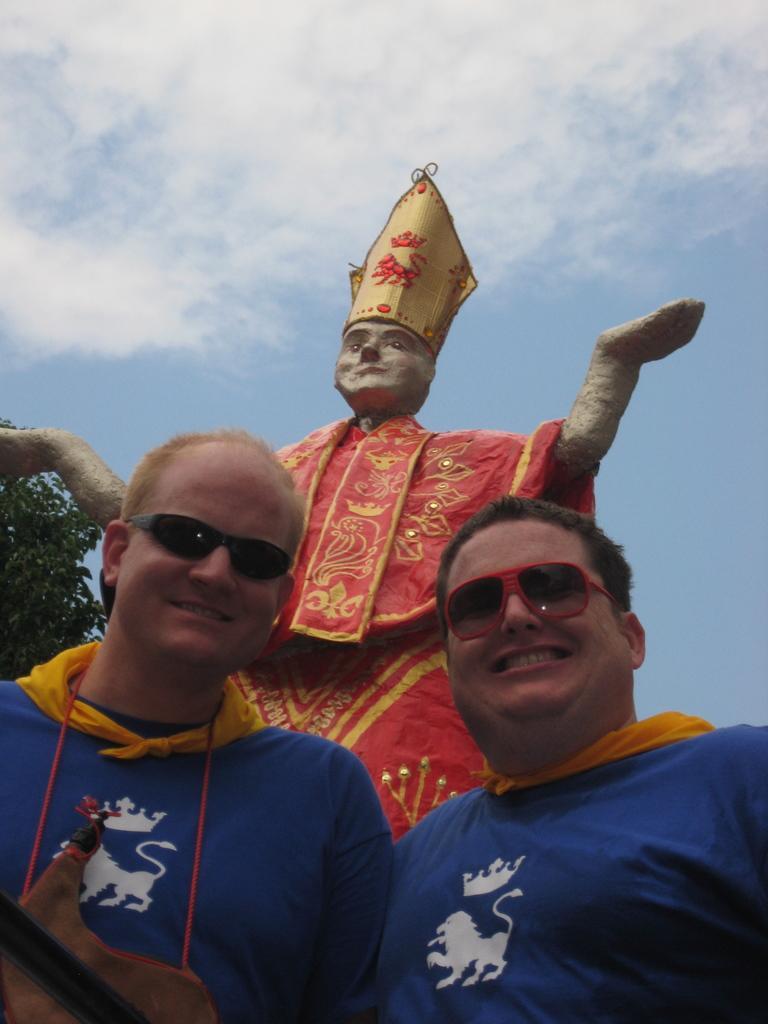In one or two sentences, can you explain what this image depicts? In the middle of the image there are two men with blue and yellow jacket and kept goggles. To the left side man around his neck there is a red thread. Behind them there is a statue with red cloth and a cap on the head. To the left side of the image there is a tree. To the top of the image there is a sky with clouds. 